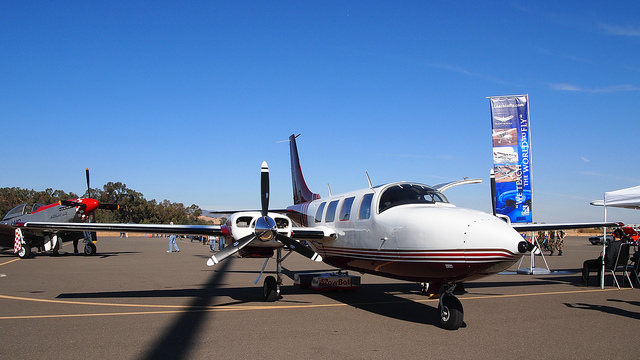<image>What color is the propeller? I am not sure, the color of the propeller might be black, black and white, or silver. What type of plane is this? I don't know what type of plane this is. It could be a small commuter, propeller plane, jet, or a twin engine. What color is the propeller? It is not certain what color the propeller is. It can be seen as black, black and white, or silver. What type of plane is this? I am not sure what type of plane it is. It can be seen as 'small', 'small commuter', 'prop plane', 'airplane', 'jet', or 'private'. 